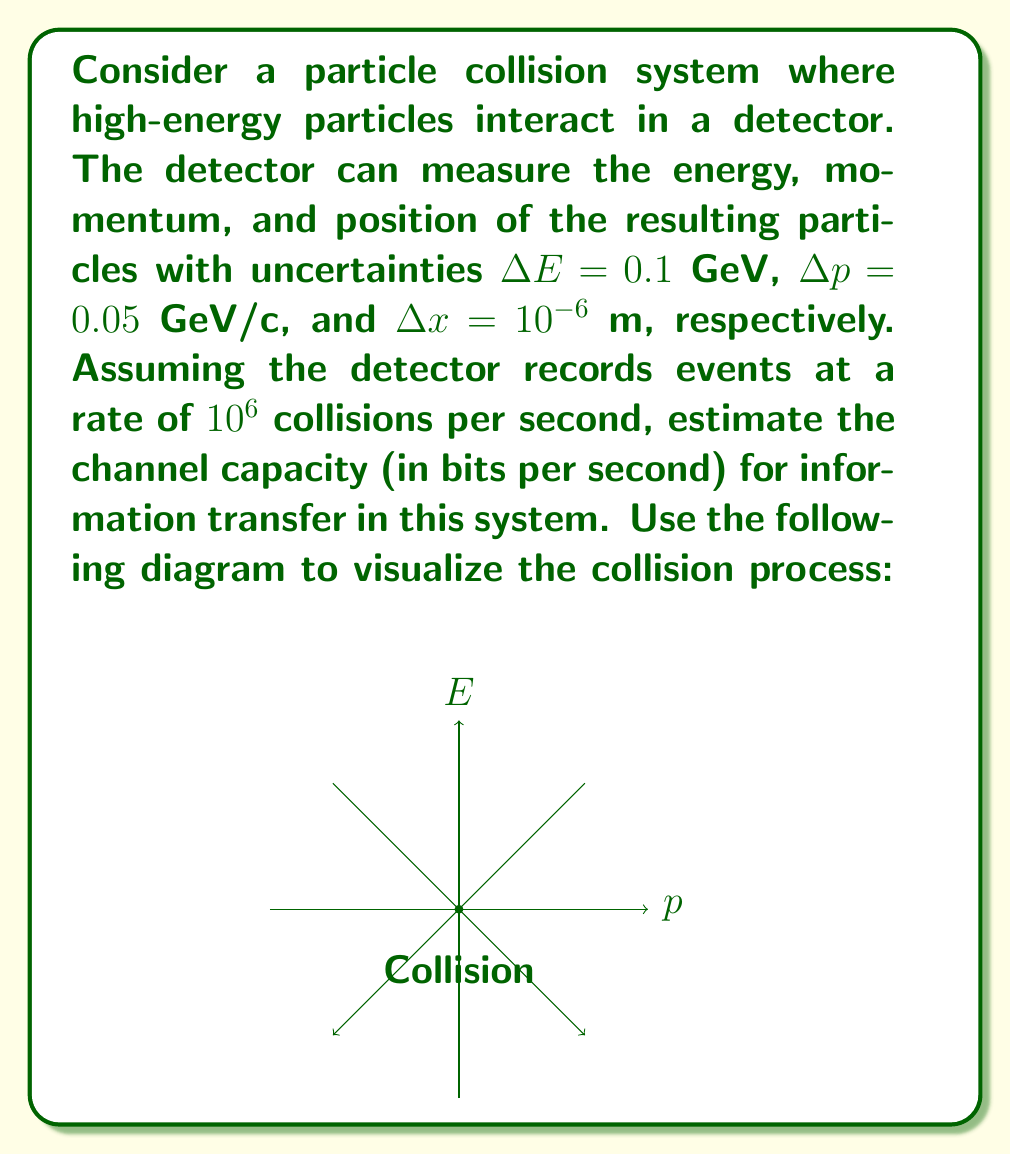Can you solve this math problem? To estimate the channel capacity, we'll use Shannon's information theory and follow these steps:

1) First, we need to calculate the information content of each measurement. For a continuous variable with uncertainty $\Delta x$, the information content is approximately:

   $I = \log_2(\frac{x_{max} - x_{min}}{\Delta x})$ bits

2) For energy measurement:
   Assuming the energy range is 0-100 GeV,
   $I_E = \log_2(\frac{100}{0.1}) \approx 10$ bits

3) For momentum measurement:
   Assuming the momentum range is 0-100 GeV/c,
   $I_p = \log_2(\frac{100}{0.05}) \approx 11$ bits

4) For position measurement:
   Assuming the detector size is 1 m,
   $I_x = \log_2(\frac{1}{10^{-6}}) = 20$ bits

5) Total information per particle:
   $I_{total} = I_E + I_p + I_x = 10 + 11 + 20 = 41$ bits

6) Assuming an average of 100 particles per collision:
   Information per collision = $41 \times 100 = 4100$ bits

7) Channel capacity:
   With $10^6$ collisions per second,
   Capacity = $4100 \times 10^6 = 4.1 \times 10^9$ bits/second

Therefore, the estimated channel capacity is approximately $4.1 \times 10^9$ bits per second or 4.1 Gbps.
Answer: 4.1 Gbps 